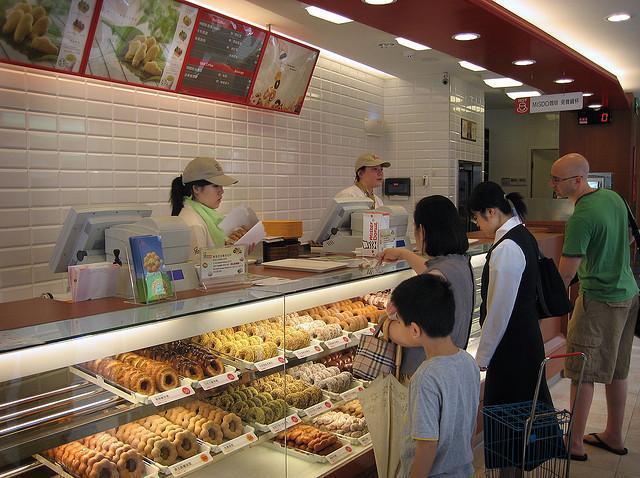How many workers are there?
Give a very brief answer. 2. How many people are in the picture?
Give a very brief answer. 5. How many black railroad cars are at the train station?
Give a very brief answer. 0. 